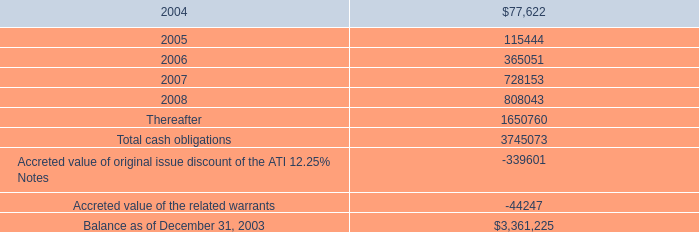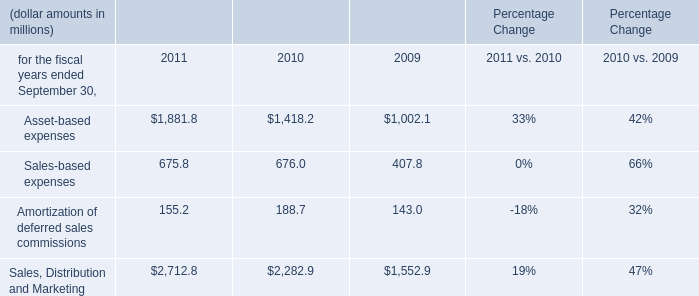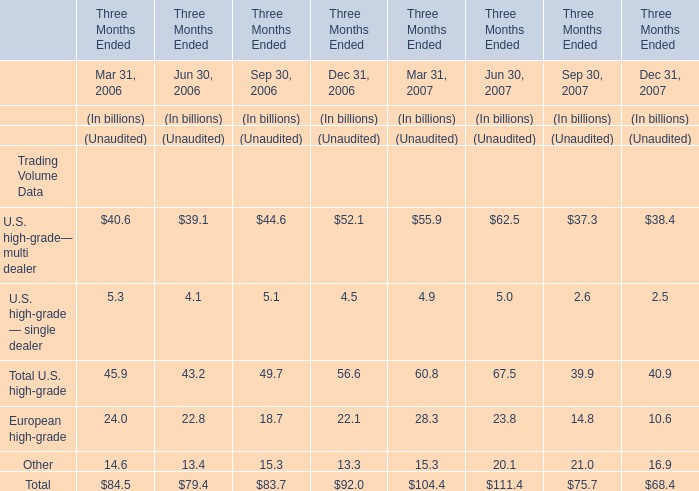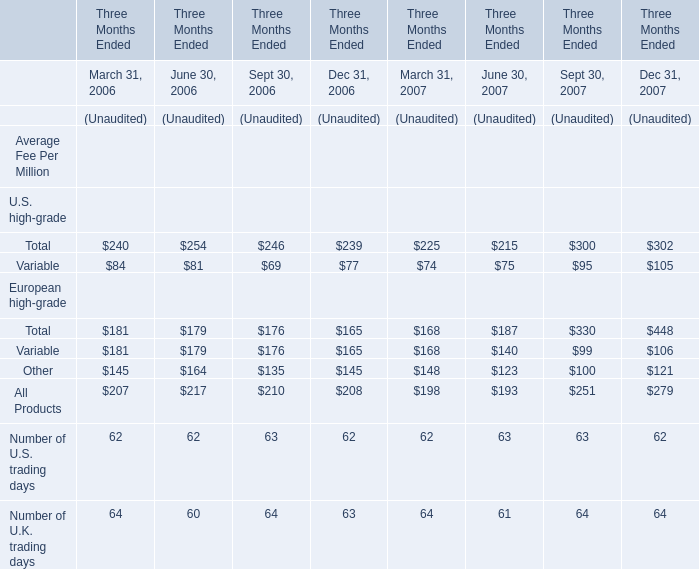For Jun 30,what year is Total Trading Volume less,if unaudited? 
Answer: 2006. 